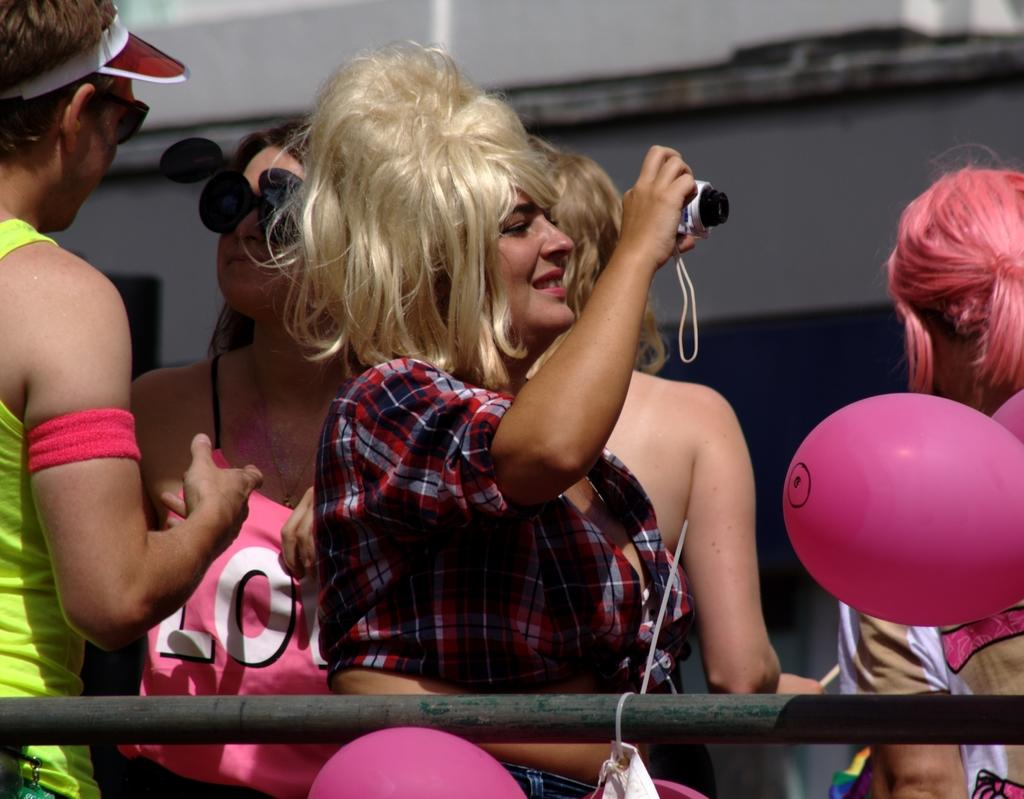What object made of metal can be seen in the image? There is a metal rod in the image. What are the balloons associated with in the image? The balloons are associated with the people in the image. Can you describe the people in the image? There are people in the image, but their specific characteristics are not mentioned in the facts. What is visible in the background of the image? There is a wall in the background of the image. How does the sense of smell play a role in the image? The sense of smell is not mentioned in the facts, so it cannot be determined how it plays a role in the image. Can you describe the action of smashing the metal rod in the image? There is no action of smashing the metal rod in the image; it is simply present. 